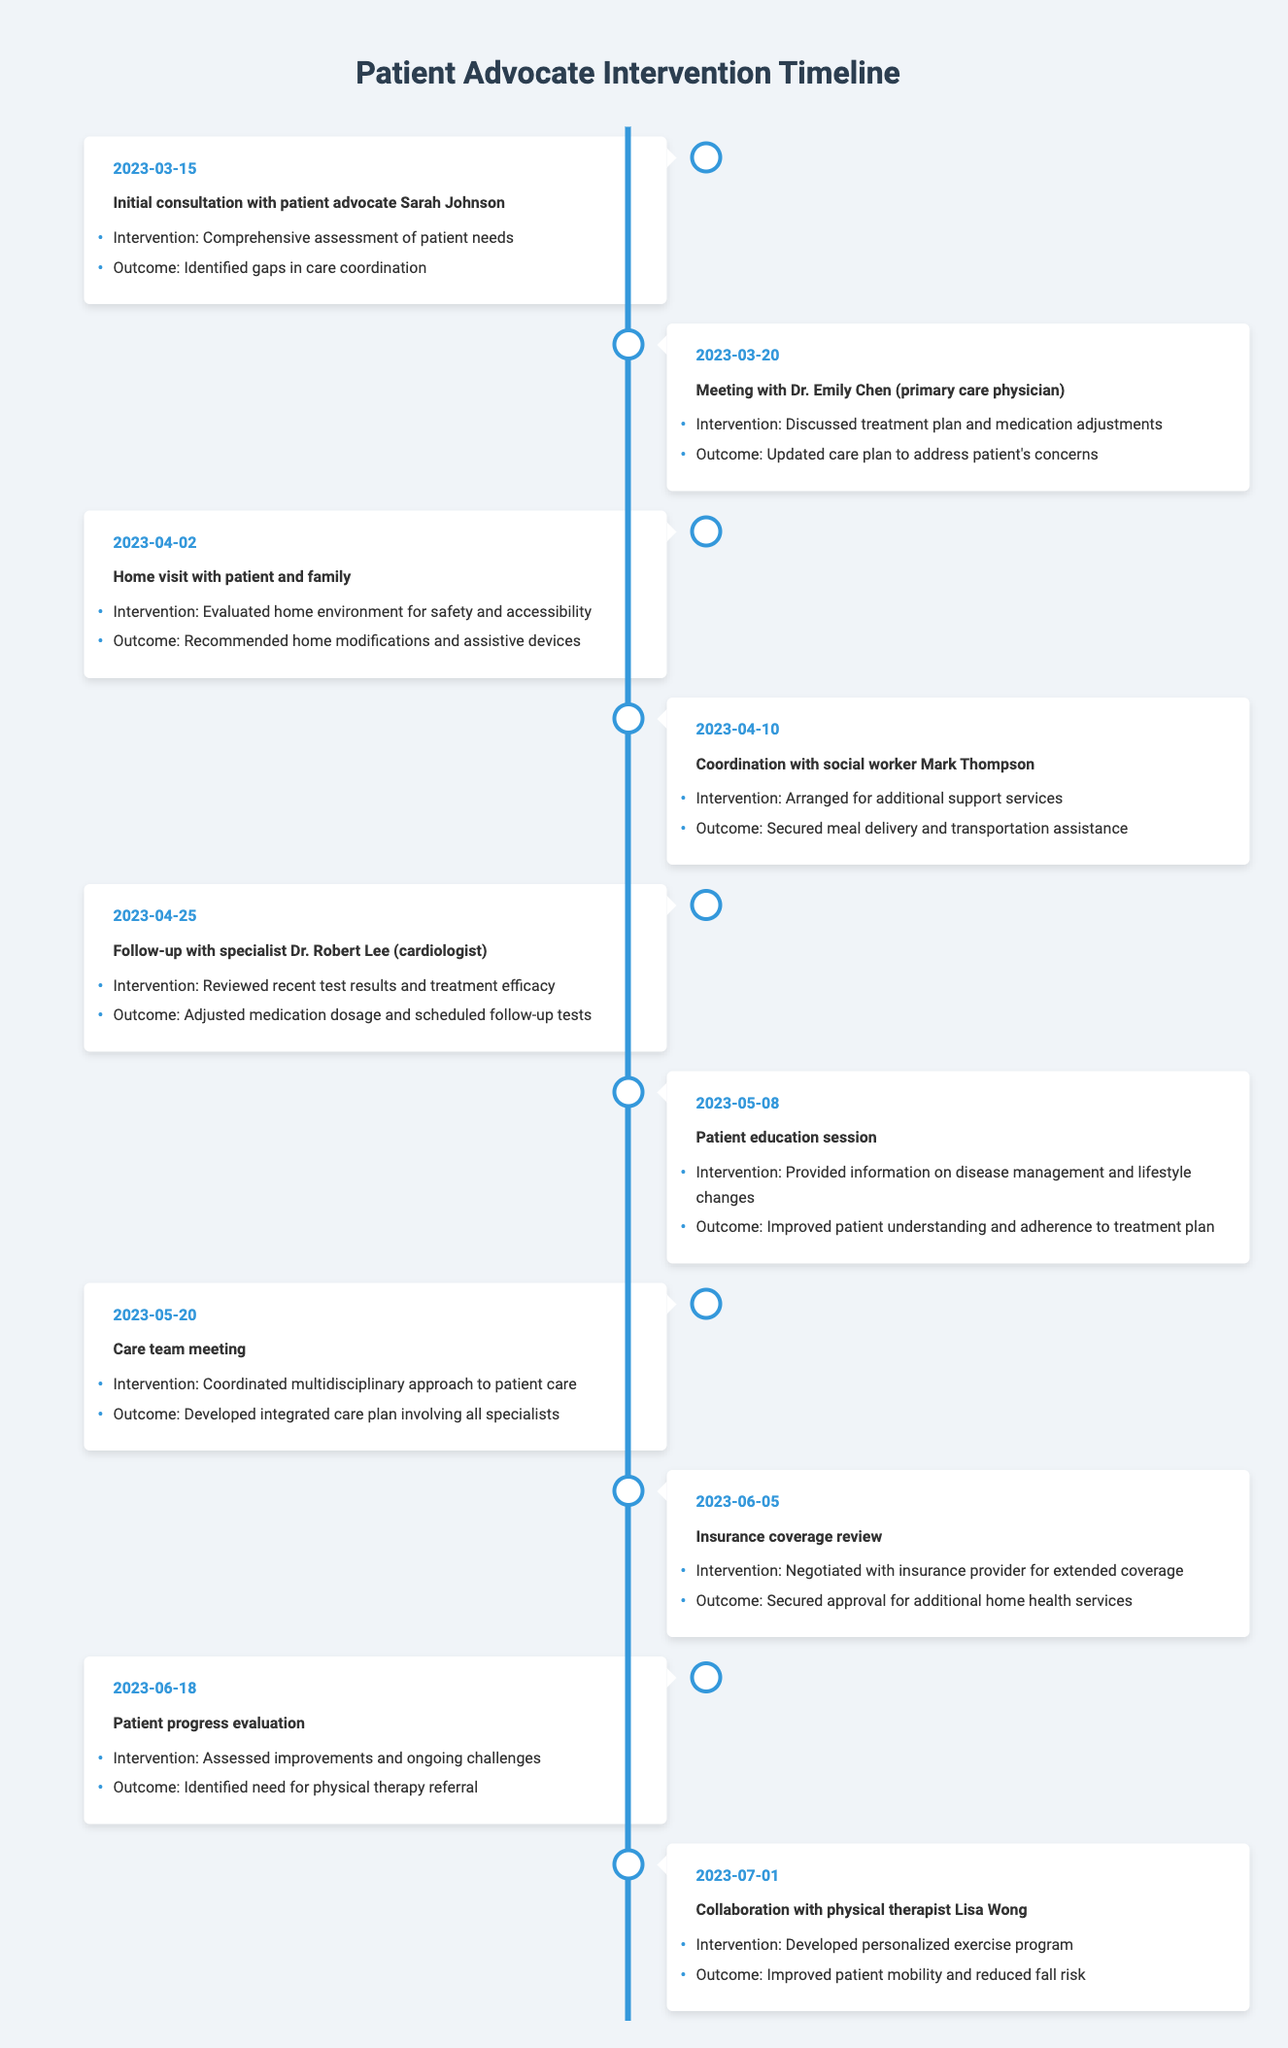What date did the initial consultation with the patient advocate occur? The timeline shows the event "Initial consultation with patient advocate Sarah Johnson" occurring on the date "2023-03-15". Thus, that is the answer.
Answer: 2023-03-15 What was the outcome of the home visit on April 2, 2023? The timeline lists the home visit on that date, with the outcome stated as "Recommended home modifications and assistive devices". Therefore, this is the correct answer.
Answer: Recommended home modifications and assistive devices How many interventions were focused on enhancing patient education? The timeline includes two events that are focused on patient education: the "Patient education session" on May 8, 2023, and the "Care team meeting" on May 20, 2023, where education about treatment plans may have been discussed. Therefore, there are two notable interventions related to education in the timeline.
Answer: 2 Did Sarah Johnson secure any insurance approvals for the patient? The timeline states on June 5, 2023, that the intervention involved negotiating with the insurance provider and resulted in the outcome of "Secured approval for additional home health services". Thus, this confirms that Sarah Johnson did secure insurance approvals.
Answer: Yes What is the total number of follow-up events listed in the timeline? There are three follow-up events mentioned in the timeline: the follow-up with the cardiologist on April 25, the patient progress evaluation on June 18, and the final collaboration with the physical therapist on July 1. Thus, by counting these events, we determine there are three follow-ups.
Answer: 3 On what date was the patient's home environment evaluated, and what was the intervention? The timeline shows that on April 2, 2023, the event of evaluating the home environment took place. The intervention was "Evaluated home environment for safety and accessibility". Therefore, both pieces of information are derived from the same timeline entry.
Answer: April 2, 2023; Evaluated home environment for safety and accessibility What outcome was achieved from the meeting with Dr. Emily Chen? The timeline provides that in the meeting with Dr. Emily Chen on March 20, 2023, the intervention was to discuss the treatment plan, and the outcome was "Updated care plan to address patient's concerns". Therefore, this is the achieved outcome.
Answer: Updated care plan to address patient's concerns Identify the event that resulted in the development of an integrated care plan involving all specialists. The timeline specifies the care team meeting on May 20, 2023, where the intervention related to coordinating a multidisciplinary approach was conducted, leading to the outcome of developing an integrated care plan involving all specialists. Hence, this is the relevant event.
Answer: Care team meeting on May 20, 2023 